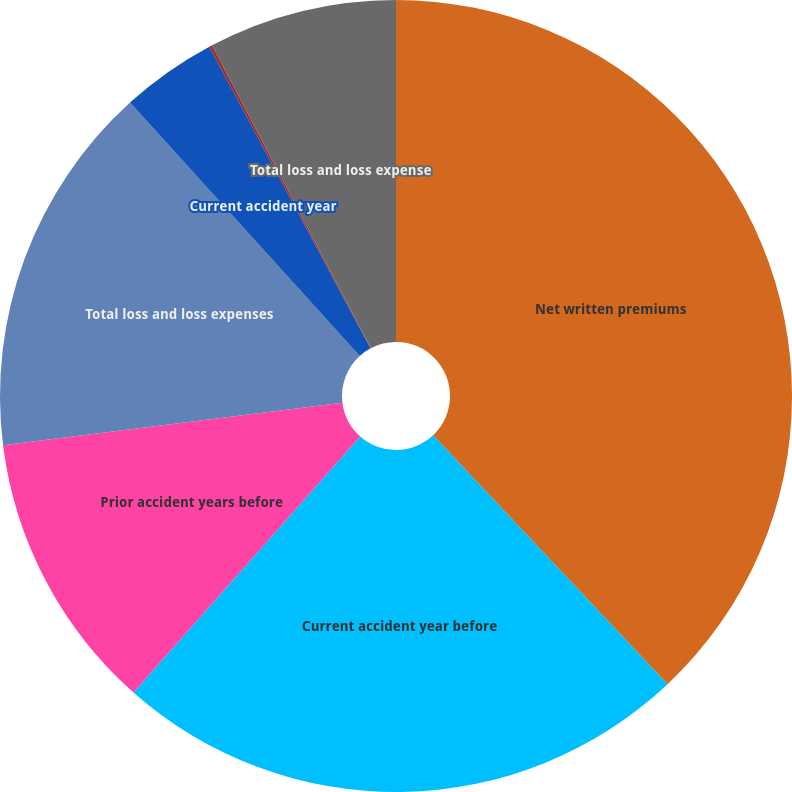Convert chart. <chart><loc_0><loc_0><loc_500><loc_500><pie_chart><fcel>Net written premiums<fcel>Current accident year before<fcel>Prior accident years before<fcel>Total loss and loss expenses<fcel>Current accident year<fcel>Prior accident years<fcel>Total loss and loss expense<nl><fcel>37.97%<fcel>23.56%<fcel>11.48%<fcel>15.26%<fcel>3.91%<fcel>0.12%<fcel>7.69%<nl></chart> 